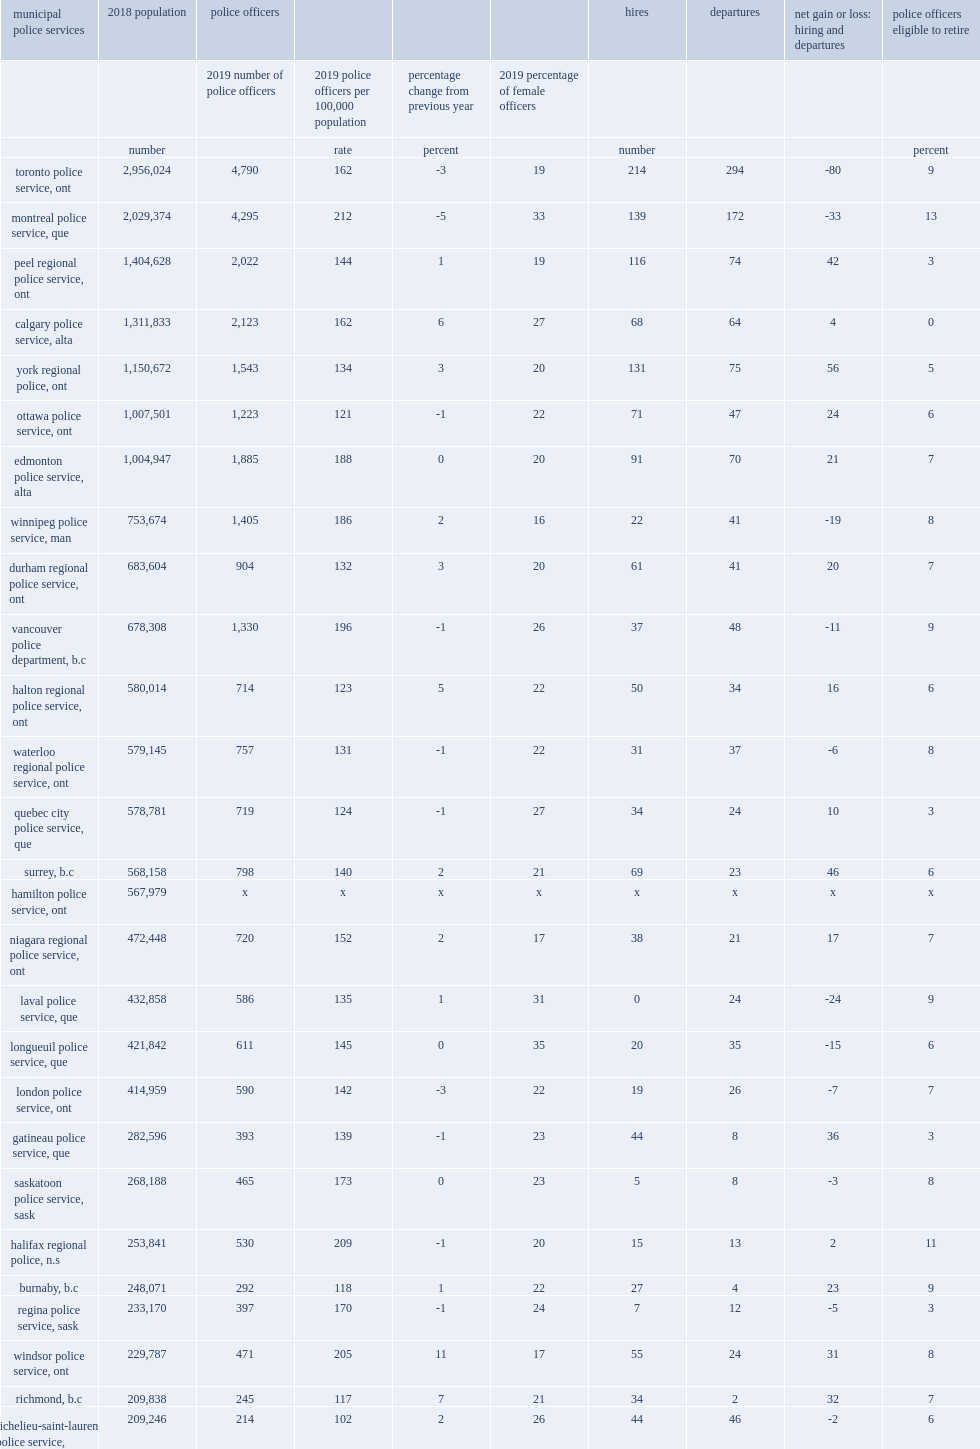Which police service reported the largest decreases in the rate of police strength? Montreal police service, que. Where the largest increases in the rate of police strength were seen? Windsor police service, ont. Where the highest rate of police strength was reported? Victoria police department, b.c. Where can the lowest rates of municipal police strength be found? Richelieu-saint-laurent police service, que. Where can the second lowest rates of municipal police strength be found? Roussillon regional police service, que. Where can the third lowest rates of municipal police strength be found? Levis police service, que. 